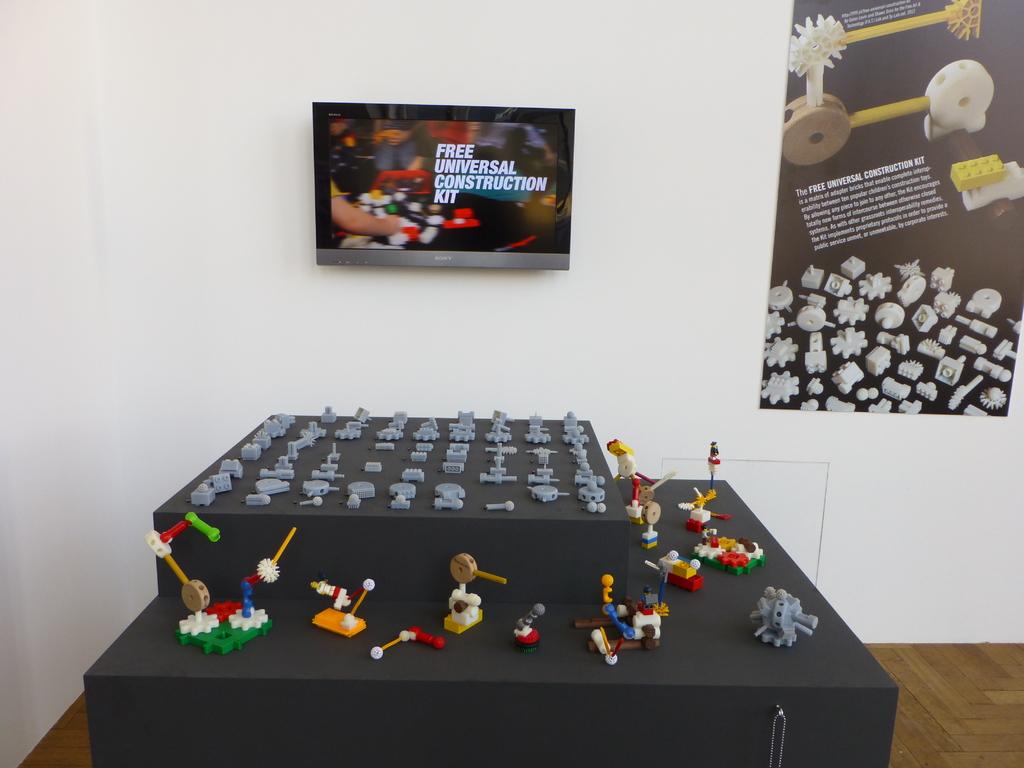What kit is being shown on the screen?
Your response must be concise. Free universal construction. What does it say on the tv screen?
Keep it short and to the point. Free universal construction kit. 